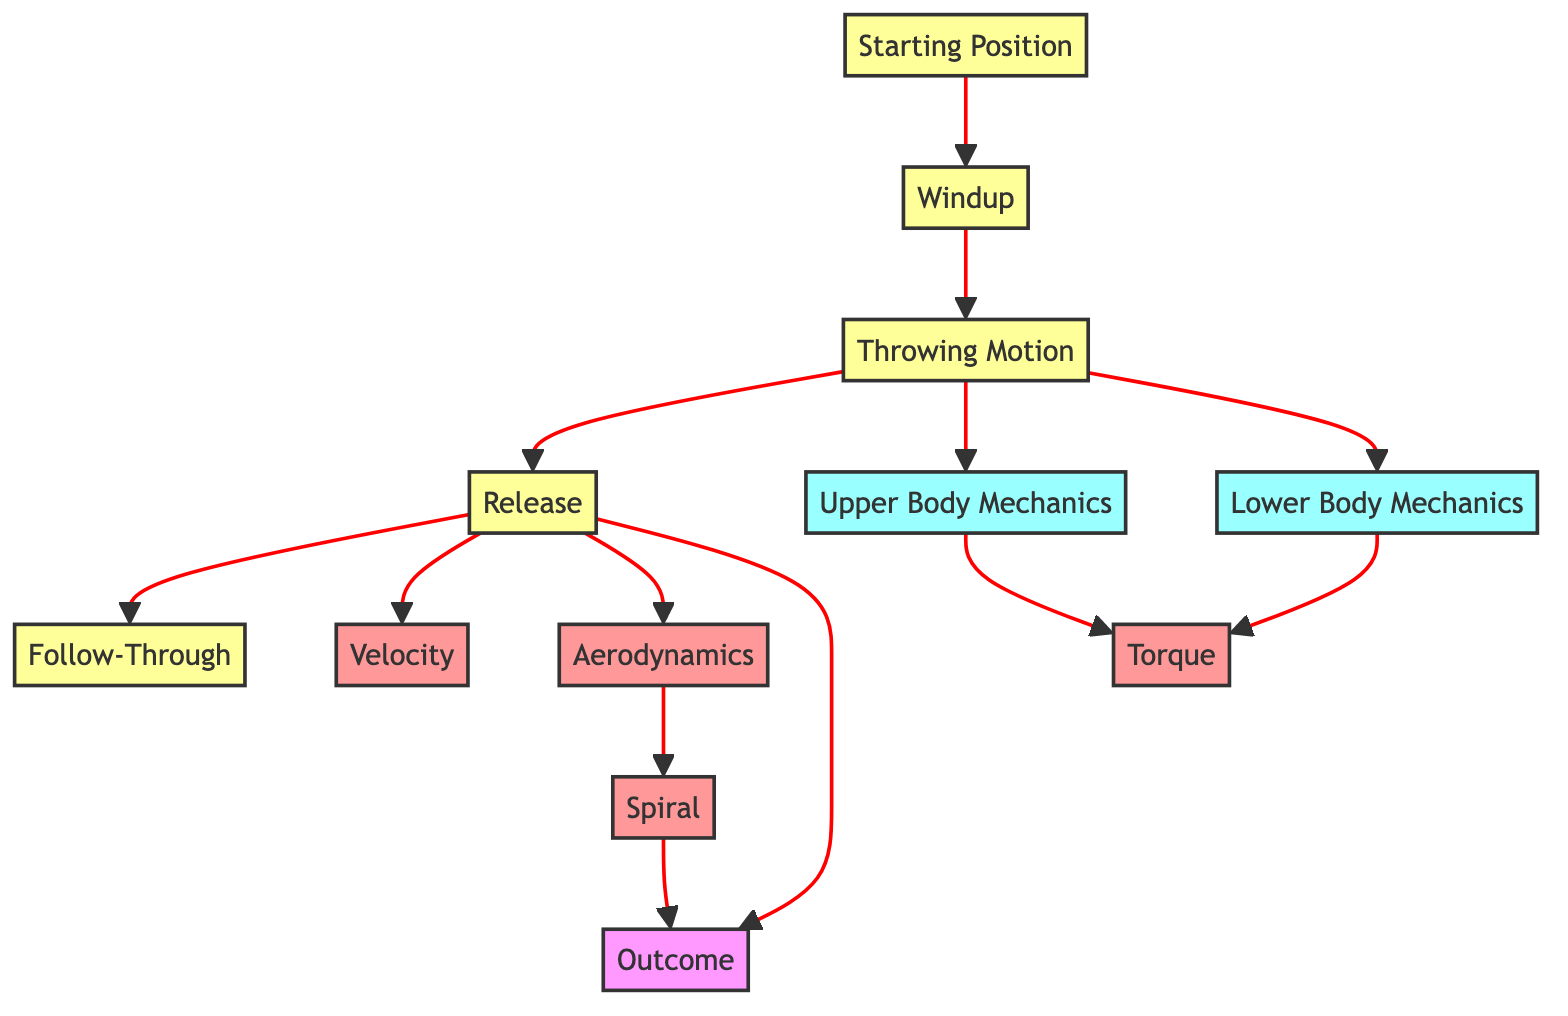What is the first node in the diagram? The first node in the diagram is labeled "Starting Position," which is depicted at the beginning of the flowchart.
Answer: Starting Position What is the last node in the diagram? The last node in the diagram is labeled "Outcome," which represents the final stage after the throwing motion and its outcomes.
Answer: Outcome How many mechanics nodes are there in the diagram? The diagram contains two mechanics nodes: "Upper Body Mechanics" and "Lower Body Mechanics." Counting these gives us a total of two mechanics nodes.
Answer: 2 What does the "Throwing Motion" node connect to? The "Throwing Motion" node connects to three other nodes: "Release," "Upper Body Mechanics," and "Lower Body Mechanics." This implies that during the throwing motion, the player is engaged in both upper and lower body mechanics before releasing the ball.
Answer: Release, Upper Body Mechanics, Lower Body Mechanics How does "Torque" relate to the motion? "Torque" is a consequence of both "Upper Body Mechanics" and "Lower Body Mechanics," showing that both body sections contribute to the twisting force applied during the throw.
Answer: Upper Body Mechanics, Lower Body Mechanics Which node has a direct link to "Velocity"? The node "Release" has a direct link to "Velocity," indicating that the performance of the throw is closely related to the moment the ball is released.
Answer: Release What is a key characteristic of the "Aerodynamics" node? The "Aerodynamics" node is connected to "Spiral," which indicates the importance of the ball's spiral motion in optimizing its travel through the air.
Answer: Spiral How do "Velocity" and "Aerodynamics" relate to the "Outcome"? Both "Velocity" and "Aerodynamics" are directly connected to the "Outcome," indicating that the speed of the throw and how the ball behaves in the air significantly influence the results of the throw.
Answer: Outcome What phase follows "Follow-Through"? There are no nodes following "Follow-Through," as it represents the conclusion of the throwing process in this diagram.
Answer: None 